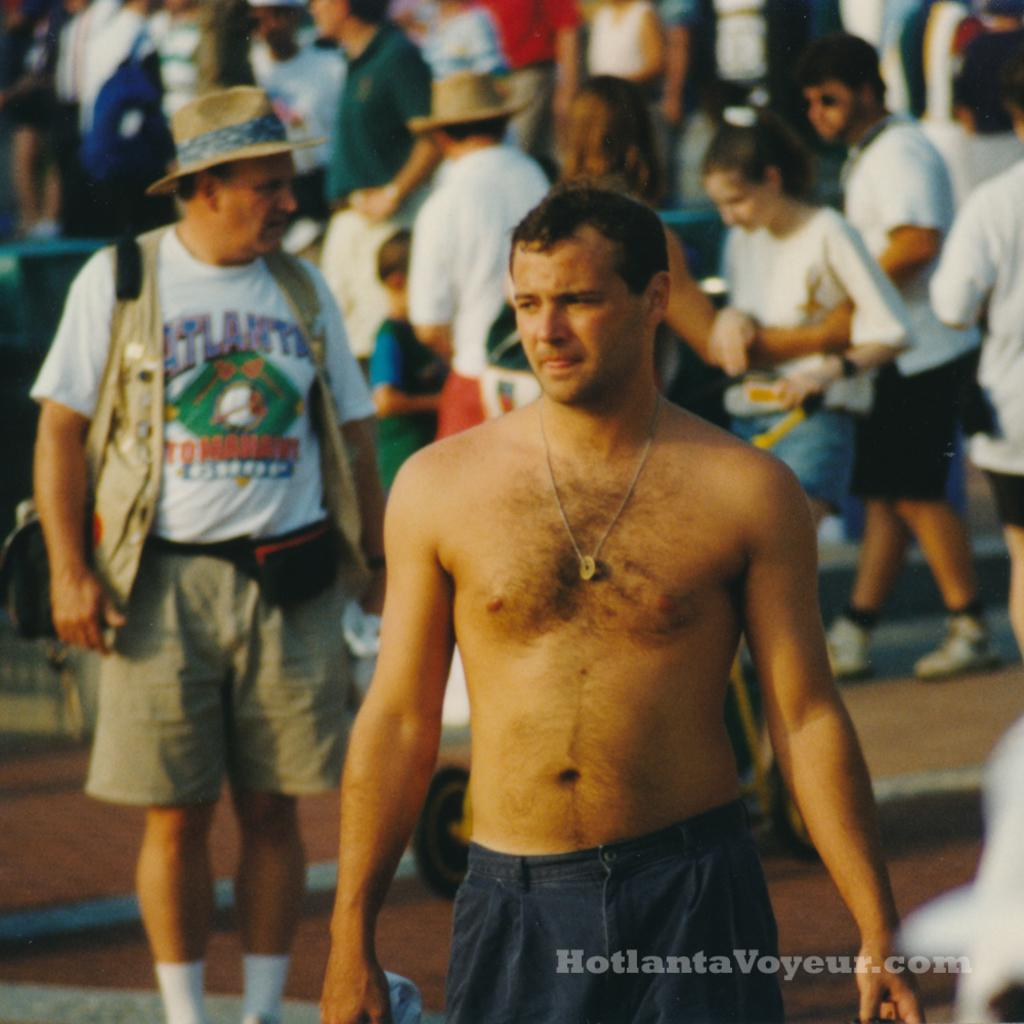<image>
Give a short and clear explanation of the subsequent image. A shirtless man wearing grey shorts with other people in the background brought to you by HoltantaVoyeur.com 